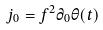Convert formula to latex. <formula><loc_0><loc_0><loc_500><loc_500>j _ { 0 } = f ^ { 2 } \partial _ { 0 } \theta ( t )</formula> 